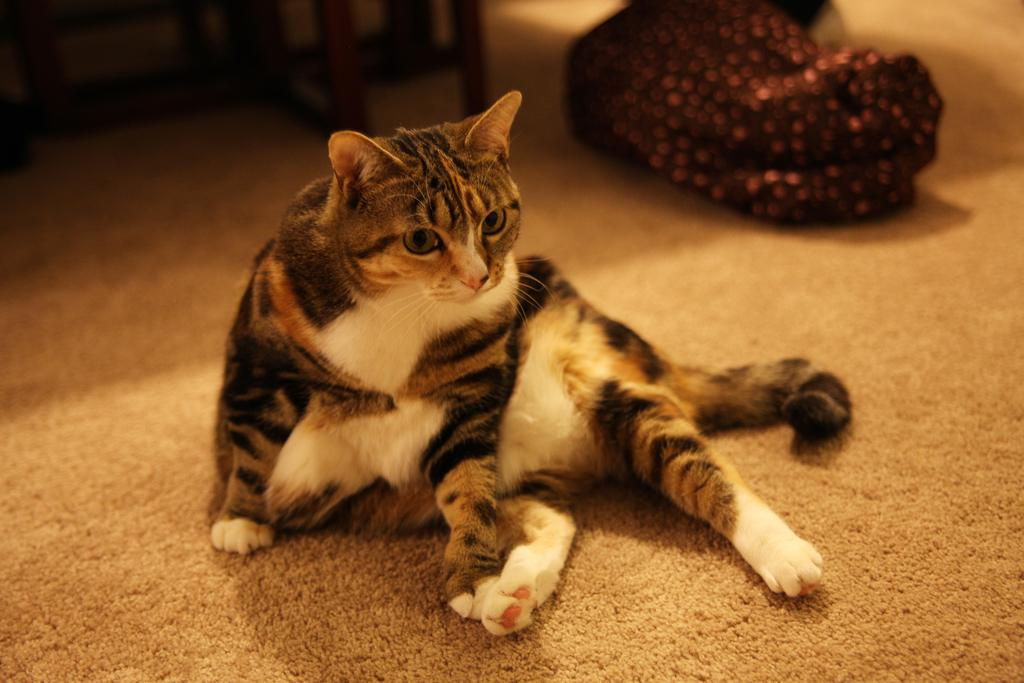What type of animal is in the image? There is a cat in the image. Where is the cat sitting? The cat is sitting on a floor mat. What can be seen on the right side of the image? There is cloth on the right side of the image. What type of material is used for the legs of the object visible at the top of the image? The legs visible at the top of the image are made of wood. What type of wine is being served at the cemetery in the image? There is no cemetery or wine present in the image; it features a cat sitting on a floor mat. 